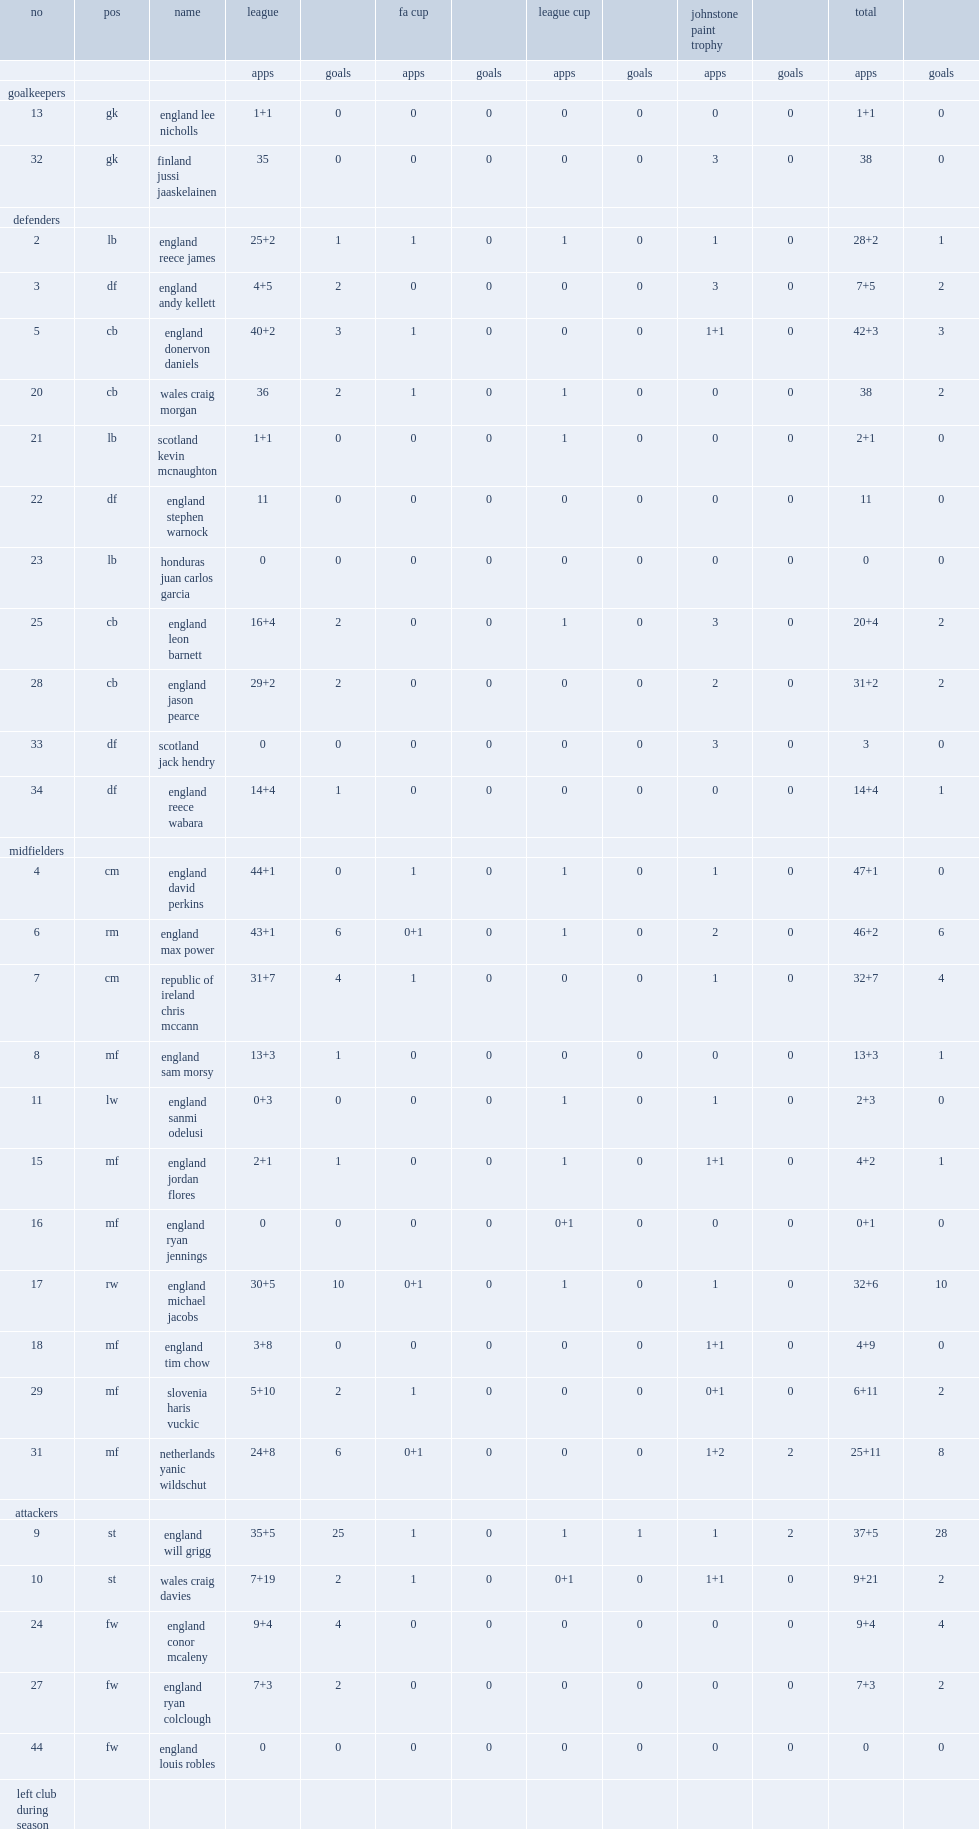What the matches did wigan athletic f.c. participate in? Fa cup league cup. 